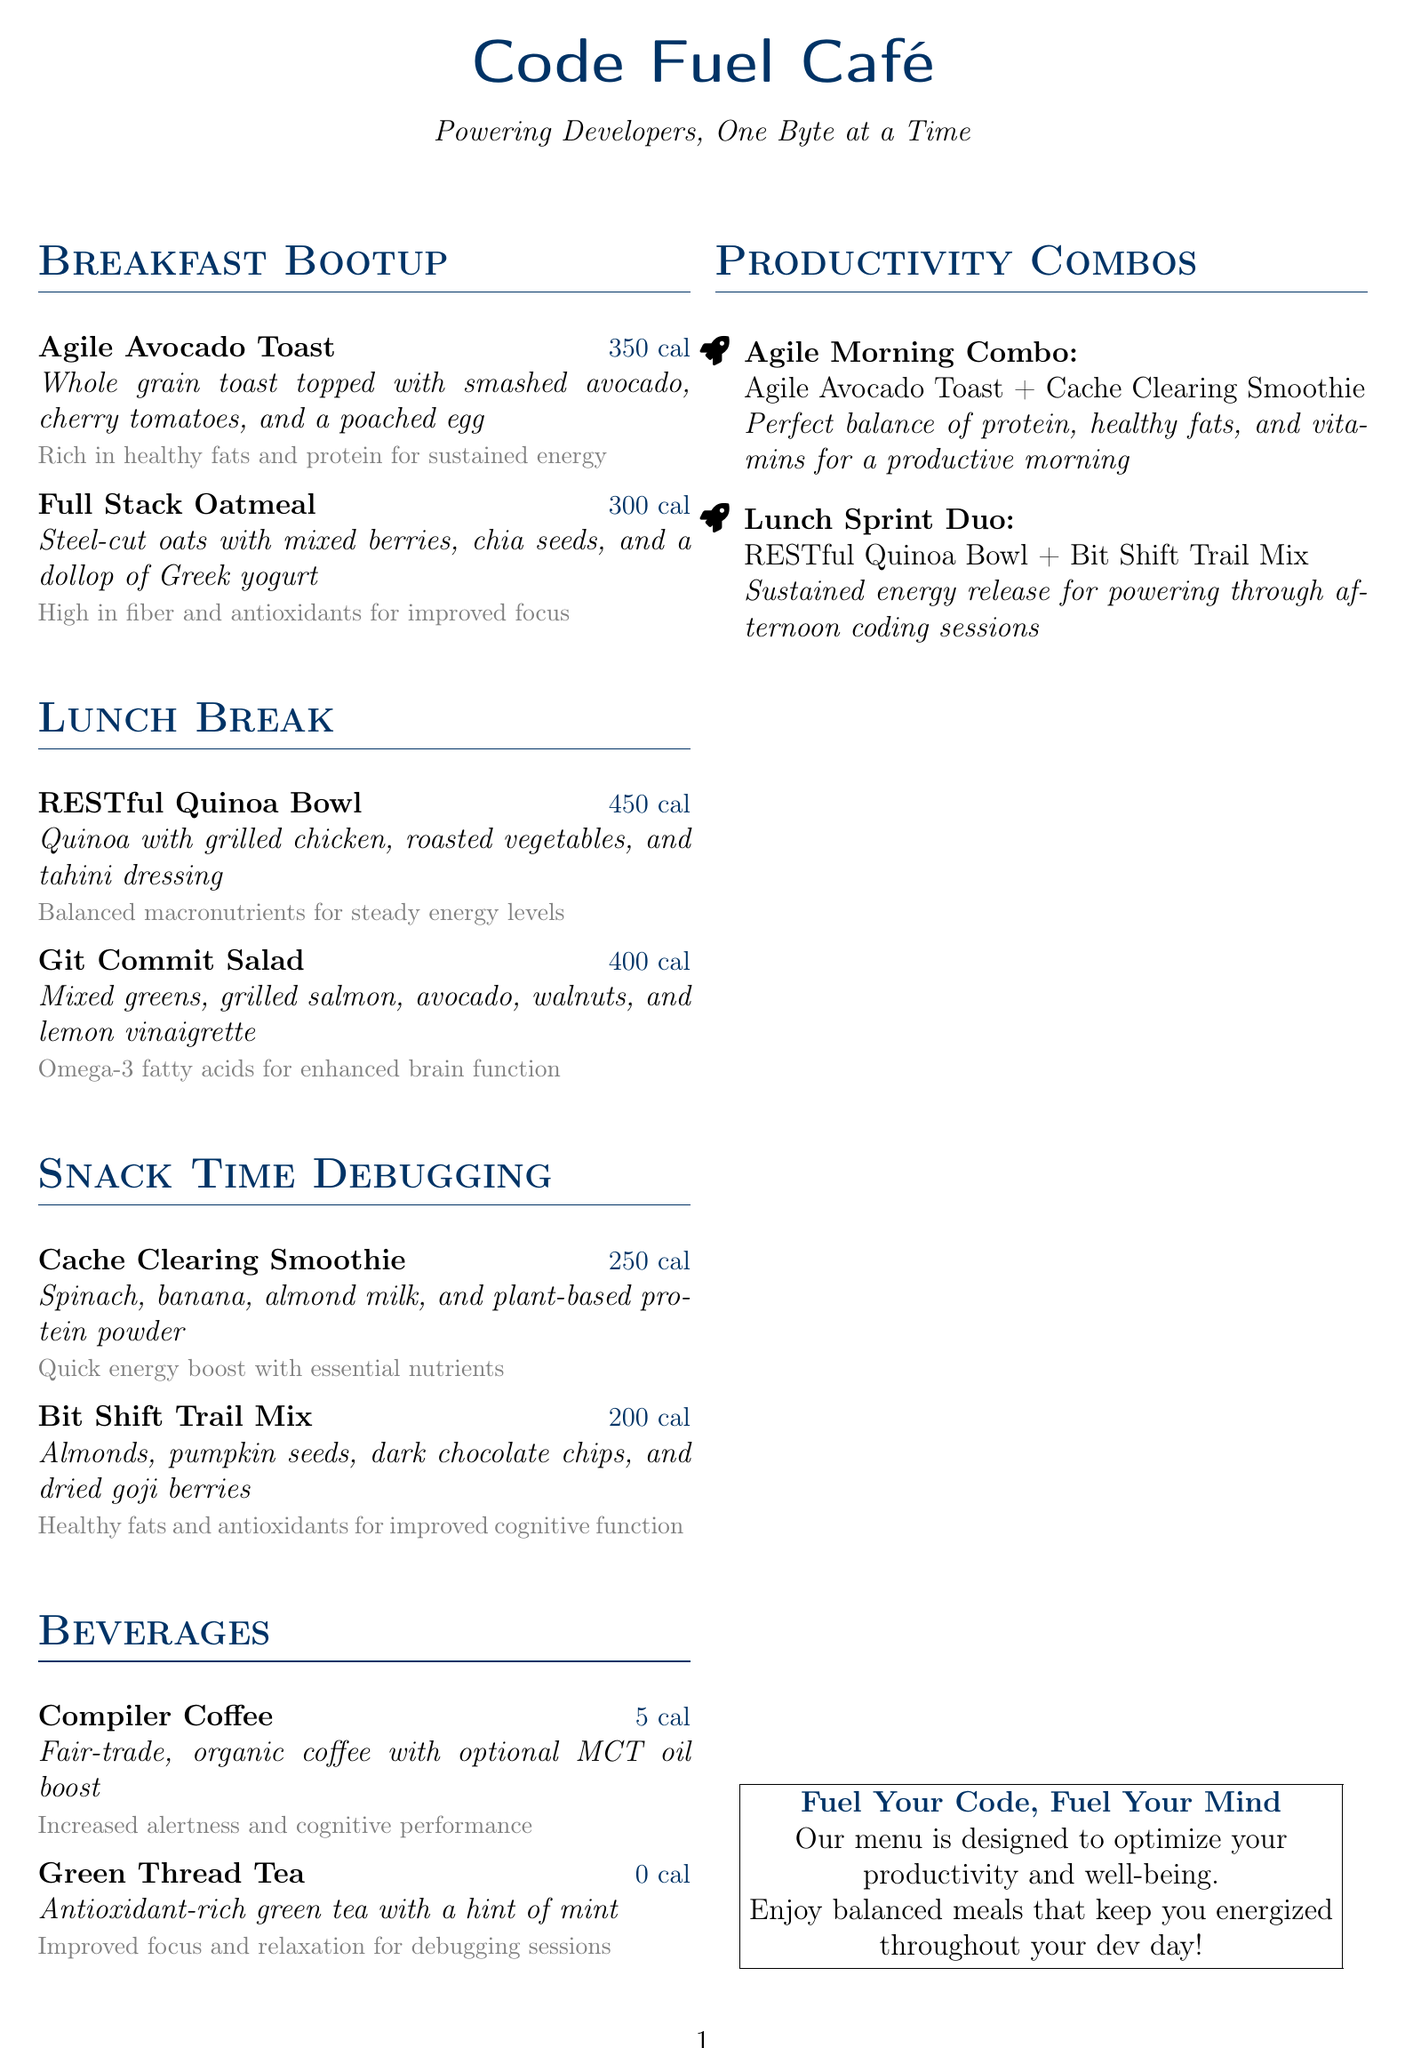what is the calorie count of Agile Avocado Toast? The document states that Agile Avocado Toast has a calorie count of 350 calories.
Answer: 350 cal what are the main ingredients of the Full Stack Oatmeal? The document lists steel-cut oats, mixed berries, chia seeds, and Greek yogurt as the main ingredients of Full Stack Oatmeal.
Answer: Steel-cut oats, mixed berries, chia seeds, Greek yogurt which beverage has the least calories? The document mentions Compiler Coffee has the least calories at 5 calories.
Answer: 5 cal what is the recommended combo for a productive morning? The document recommends the Agile Morning Combo for a productive morning, which includes Agile Avocado Toast and Cache Clearing Smoothie.
Answer: Agile Morning Combo how many calories does the Bit Shift Trail Mix contain? The document states that Bit Shift Trail Mix contains 200 calories.
Answer: 200 cal which dish includes grilled chicken? The document says that the RESTful Quinoa Bowl includes grilled chicken.
Answer: RESTful Quinoa Bowl what nutrients does the Cache Clearing Smoothie provide? The document mentions that the Cache Clearing Smoothie provides essential nutrients and a quick energy boost.
Answer: Essential nutrients how does the Git Commit Salad benefit brain function? According to the document, Git Commit Salad contains omega-3 fatty acids that enhance brain function.
Answer: Omega-3 fatty acids what is the total calorie count of the Agile Morning Combo? The document indicates that the combined calorie count for Agile Avocado Toast (350 cal) and Cache Clearing Smoothie (250 cal) is 600 calories.
Answer: 600 cal 